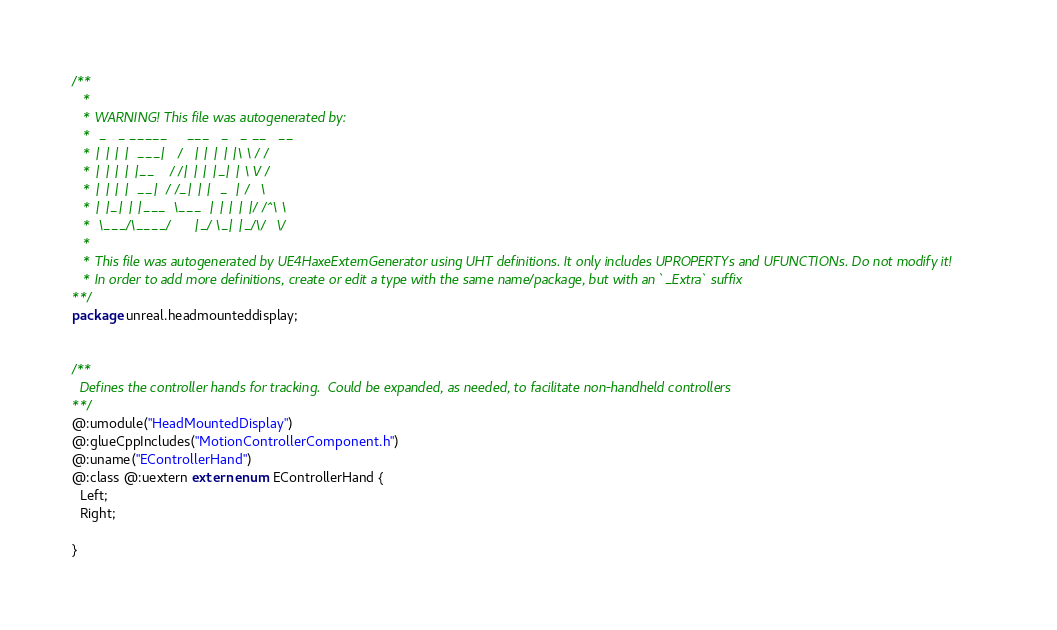<code> <loc_0><loc_0><loc_500><loc_500><_Haxe_>/**
   * 
   * WARNING! This file was autogenerated by: 
   *  _   _ _____     ___   _   _ __   __ 
   * | | | |  ___|   /   | | | | |\ \ / / 
   * | | | | |__    / /| | | |_| | \ V /  
   * | | | |  __|  / /_| | |  _  | /   \  
   * | |_| | |___  \___  | | | | |/ /^\ \ 
   *  \___/\____/      |_/ \_| |_/\/   \/ 
   * 
   * This file was autogenerated by UE4HaxeExternGenerator using UHT definitions. It only includes UPROPERTYs and UFUNCTIONs. Do not modify it!
   * In order to add more definitions, create or edit a type with the same name/package, but with an `_Extra` suffix
**/
package unreal.headmounteddisplay;


/**
  Defines the controller hands for tracking.  Could be expanded, as needed, to facilitate non-handheld controllers
**/
@:umodule("HeadMountedDisplay")
@:glueCppIncludes("MotionControllerComponent.h")
@:uname("EControllerHand")
@:class @:uextern extern enum EControllerHand {
  Left;
  Right;
  
}
</code> 